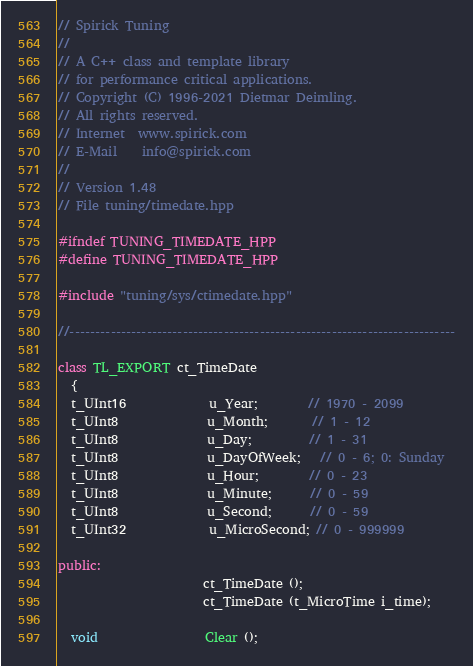<code> <loc_0><loc_0><loc_500><loc_500><_C++_>
// Spirick Tuning
//
// A C++ class and template library
// for performance critical applications.
// Copyright (C) 1996-2021 Dietmar Deimling.
// All rights reserved.
// Internet  www.spirick.com
// E-Mail    info@spirick.com
//
// Version 1.48
// File tuning/timedate.hpp

#ifndef TUNING_TIMEDATE_HPP
#define TUNING_TIMEDATE_HPP

#include "tuning/sys/ctimedate.hpp"

//---------------------------------------------------------------------------

class TL_EXPORT ct_TimeDate
  {
  t_UInt16             u_Year;        // 1970 - 2099
  t_UInt8              u_Month;       // 1 - 12
  t_UInt8              u_Day;         // 1 - 31
  t_UInt8              u_DayOfWeek;   // 0 - 6; 0: Sunday
  t_UInt8              u_Hour;        // 0 - 23
  t_UInt8              u_Minute;      // 0 - 59
  t_UInt8              u_Second;      // 0 - 59
  t_UInt32             u_MicroSecond; // 0 - 999999

public:
                       ct_TimeDate ();
                       ct_TimeDate (t_MicroTime i_time);

  void                 Clear ();</code> 